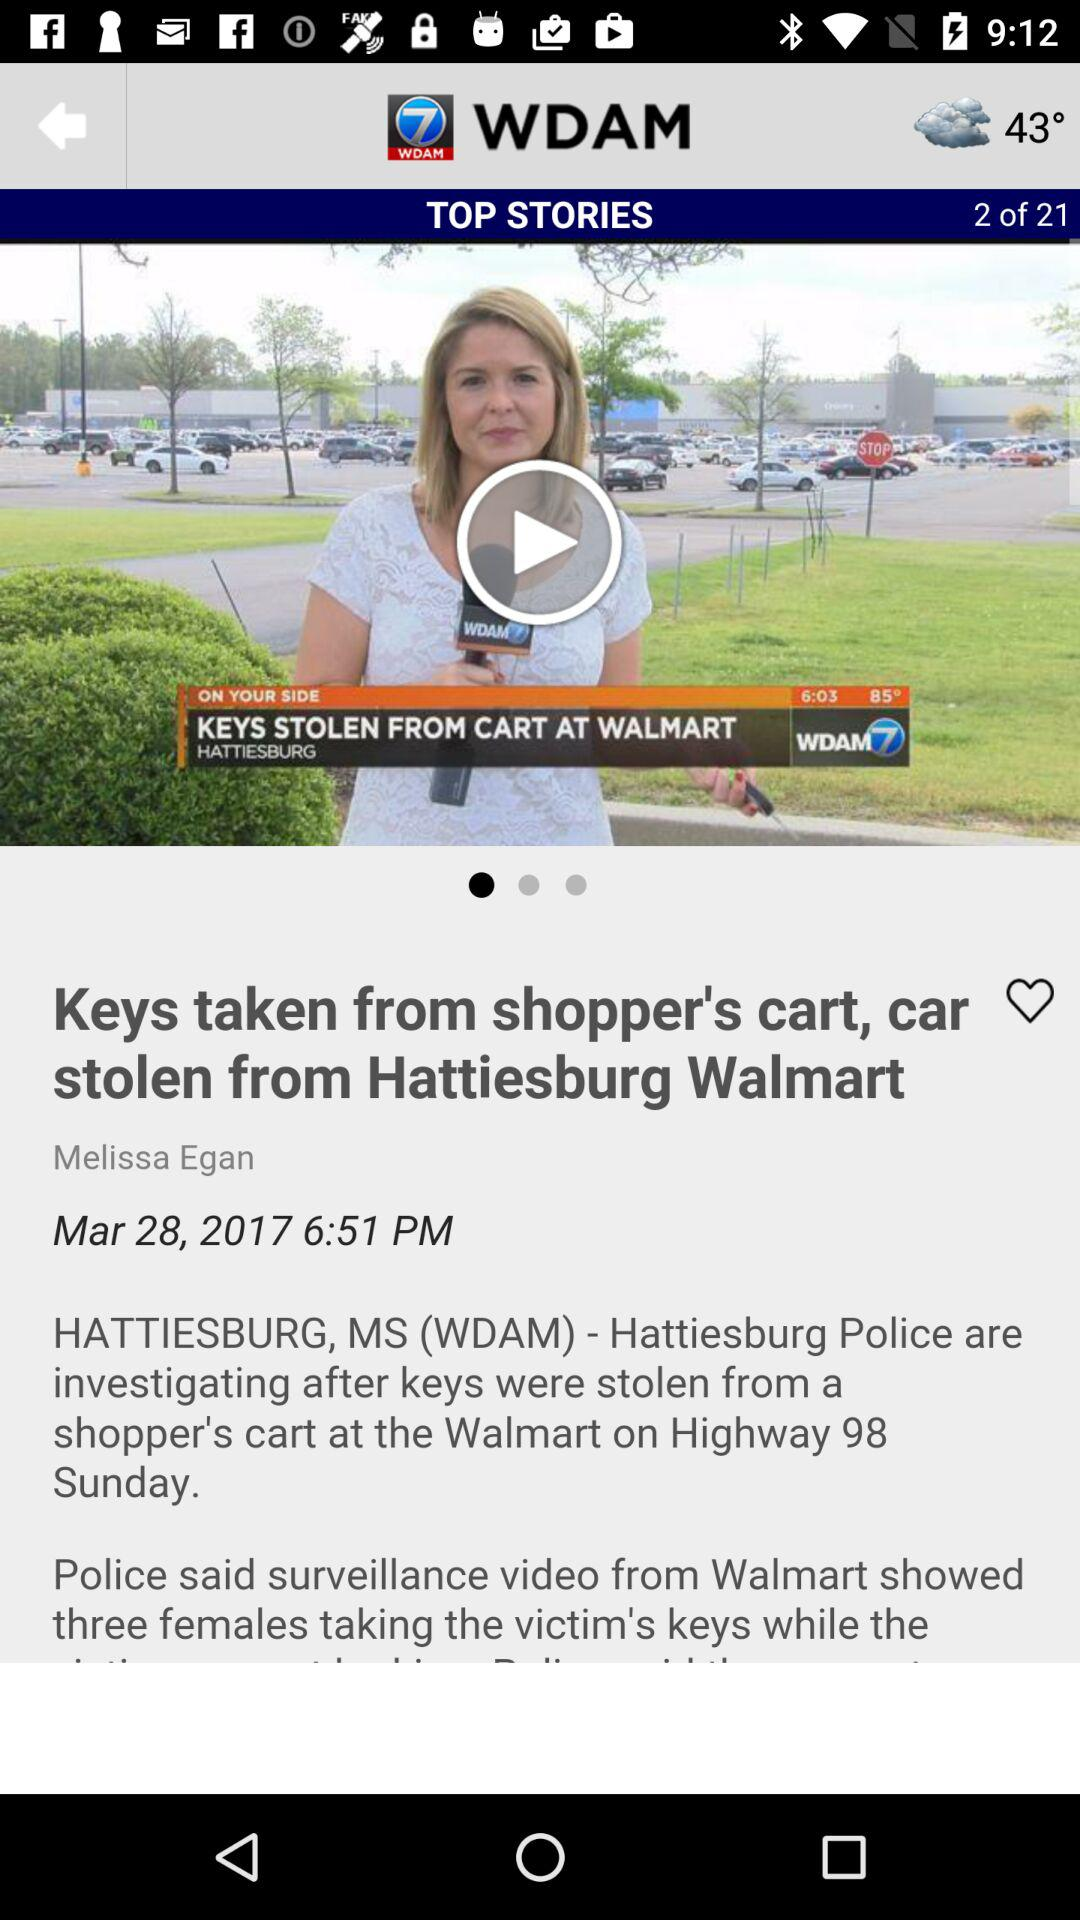What is the publication date? The publication date is March 28, 2017. 